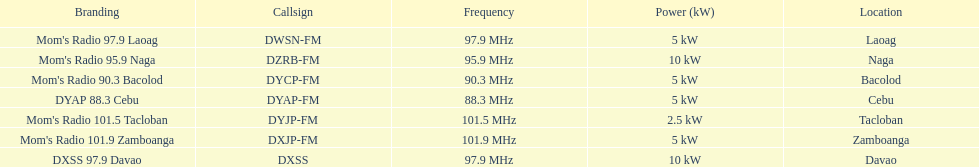What is the total number of stations with frequencies above 100 mhz? 2. 